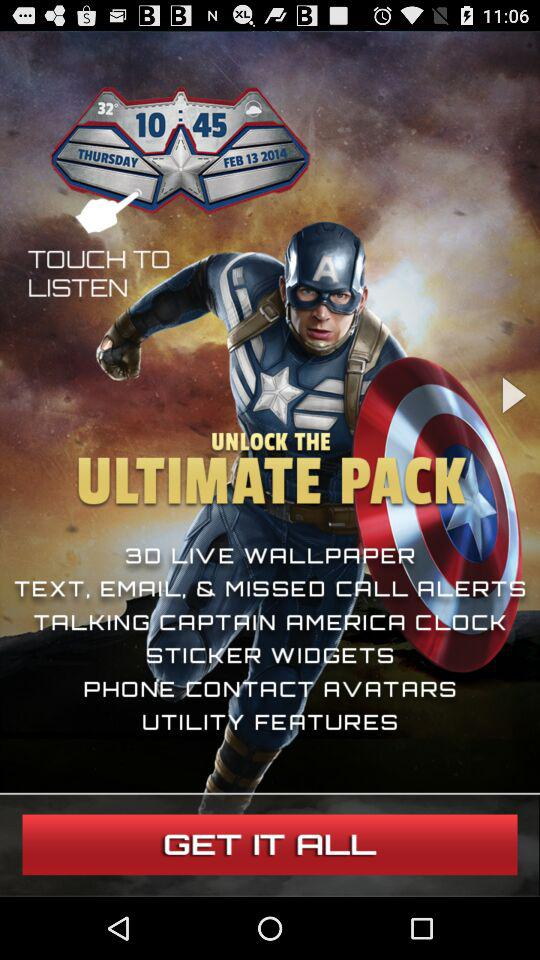What is the mentioned date and time? The mentioned date is Thursday, February 13, 2014 and the time is 10:45. 